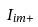<formula> <loc_0><loc_0><loc_500><loc_500>I _ { i m + }</formula> 